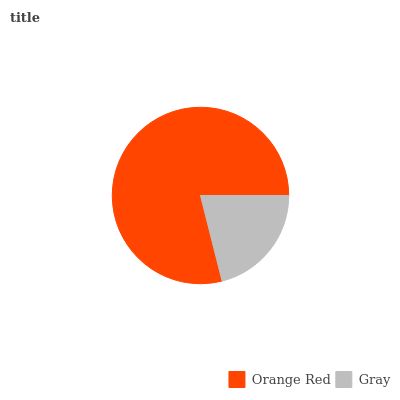Is Gray the minimum?
Answer yes or no. Yes. Is Orange Red the maximum?
Answer yes or no. Yes. Is Gray the maximum?
Answer yes or no. No. Is Orange Red greater than Gray?
Answer yes or no. Yes. Is Gray less than Orange Red?
Answer yes or no. Yes. Is Gray greater than Orange Red?
Answer yes or no. No. Is Orange Red less than Gray?
Answer yes or no. No. Is Orange Red the high median?
Answer yes or no. Yes. Is Gray the low median?
Answer yes or no. Yes. Is Gray the high median?
Answer yes or no. No. Is Orange Red the low median?
Answer yes or no. No. 